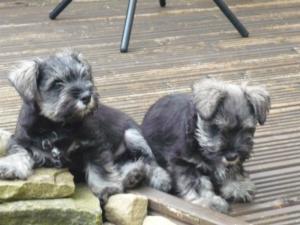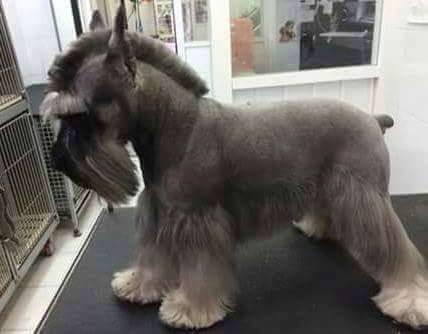The first image is the image on the left, the second image is the image on the right. Examine the images to the left and right. Is the description "One image shows a groomed schnauzer standing on an elevated black surface facing leftward." accurate? Answer yes or no. Yes. The first image is the image on the left, the second image is the image on the right. Considering the images on both sides, is "A single dog is standing and facing left in one of the images." valid? Answer yes or no. Yes. 